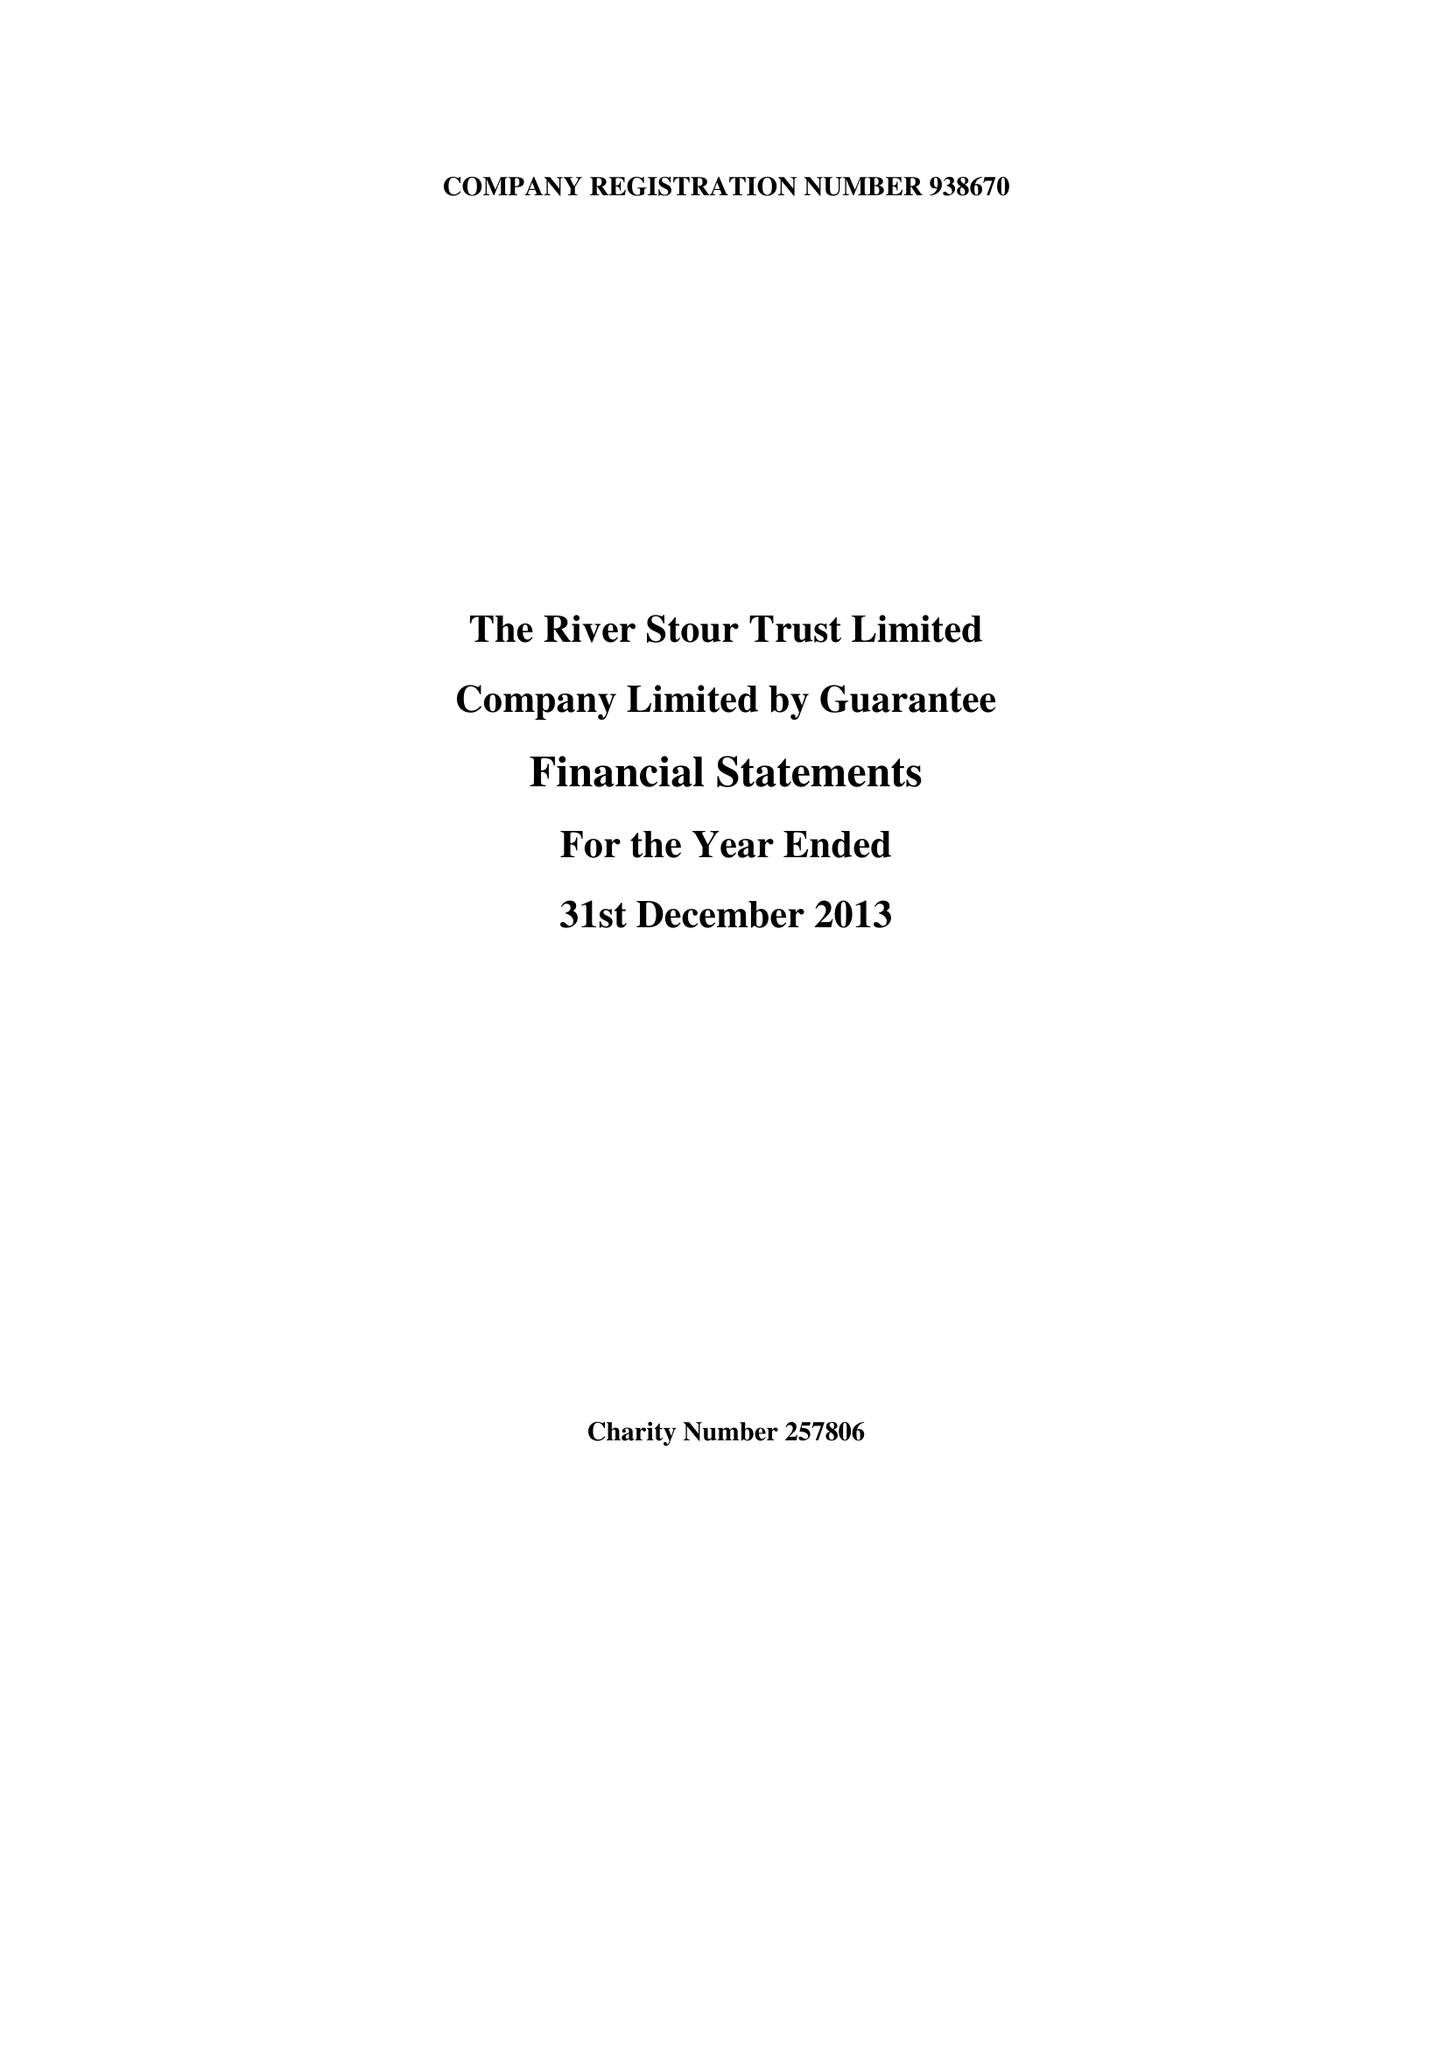What is the value for the charity_name?
Answer the question using a single word or phrase. The River Stour Trust Ltd. 